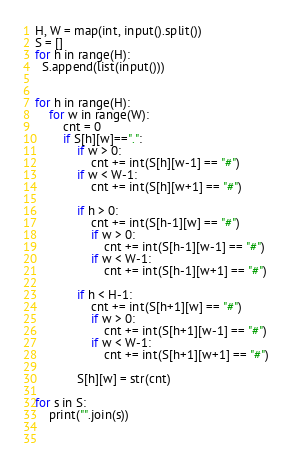Convert code to text. <code><loc_0><loc_0><loc_500><loc_500><_Python_>H, W = map(int, input().split())
S = []
for h in range(H):
  S.append(list(input()))


for h in range(H):
    for w in range(W):
        cnt = 0
        if S[h][w]==".":
            if w > 0:
                cnt += int(S[h][w-1] == "#")
            if w < W-1:
                cnt += int(S[h][w+1] == "#")
                
            if h > 0:
                cnt += int(S[h-1][w] == "#")
                if w > 0:
                    cnt += int(S[h-1][w-1] == "#")
                if w < W-1:
                    cnt += int(S[h-1][w+1] == "#")
                    
            if h < H-1:
                cnt += int(S[h+1][w] == "#")
                if w > 0:
                    cnt += int(S[h+1][w-1] == "#")
                if w < W-1:
                    cnt += int(S[h+1][w+1] == "#")
            
            S[h][w] = str(cnt)

for s in S:
    print("".join(s))
            
               </code> 